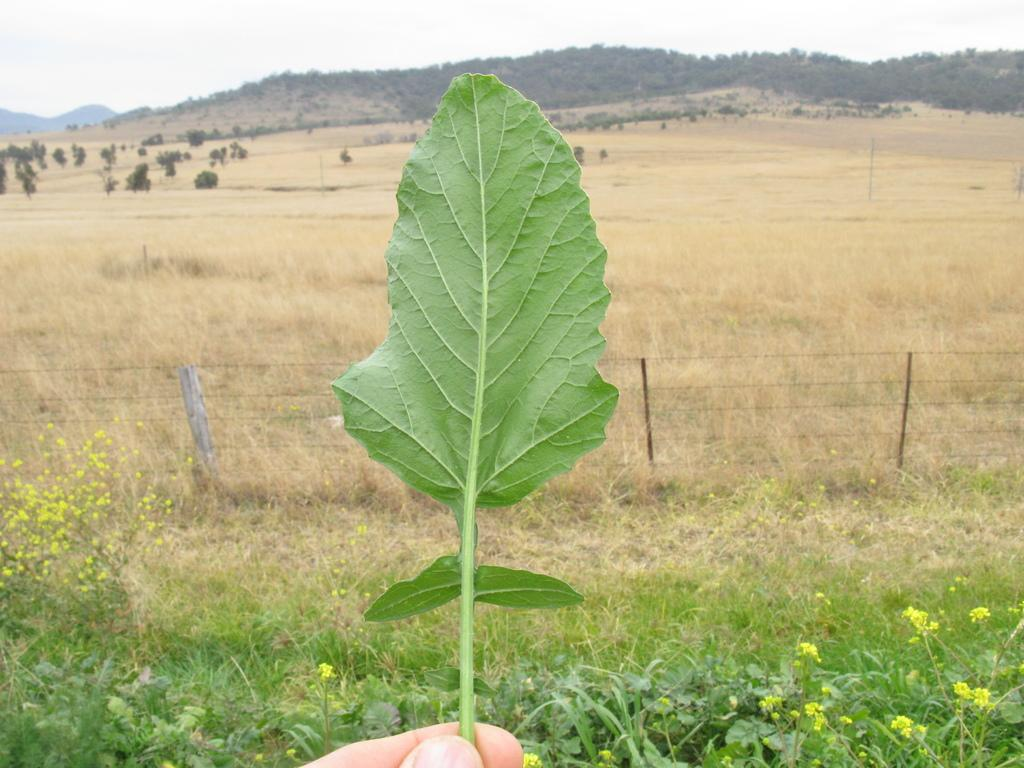Who or what is present in the image? There is a person in the image. What is the person holding in the image? The person is holding a leaf in the image. What type of vegetation can be seen in the image? There are plants and grass in the image. What geographical feature is visible in the image? There are hills in the image. What type of acoustics can be heard in the image? There is no information about acoustics in the image, as it only shows a person holding a leaf and the surrounding environment. 